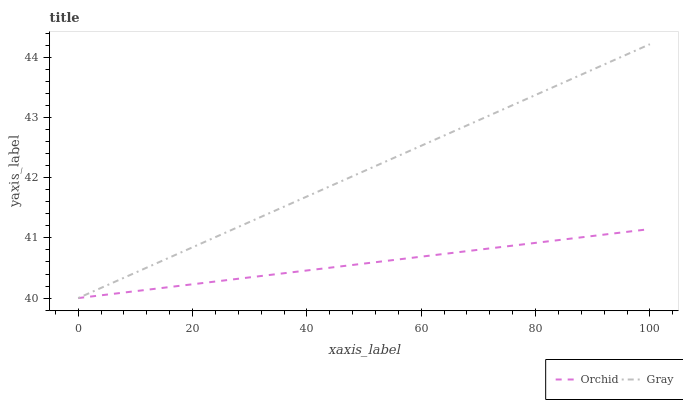Does Orchid have the minimum area under the curve?
Answer yes or no. Yes. Does Gray have the maximum area under the curve?
Answer yes or no. Yes. Does Orchid have the maximum area under the curve?
Answer yes or no. No. Is Gray the smoothest?
Answer yes or no. Yes. Is Orchid the roughest?
Answer yes or no. Yes. Is Orchid the smoothest?
Answer yes or no. No. Does Gray have the lowest value?
Answer yes or no. Yes. Does Gray have the highest value?
Answer yes or no. Yes. Does Orchid have the highest value?
Answer yes or no. No. Does Gray intersect Orchid?
Answer yes or no. Yes. Is Gray less than Orchid?
Answer yes or no. No. Is Gray greater than Orchid?
Answer yes or no. No. 